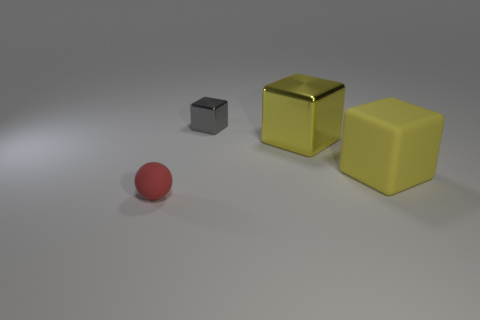Add 2 small gray objects. How many objects exist? 6 Subtract all spheres. How many objects are left? 3 Subtract 0 brown blocks. How many objects are left? 4 Subtract all small red spheres. Subtract all big green rubber cylinders. How many objects are left? 3 Add 2 matte objects. How many matte objects are left? 4 Add 2 tiny gray metal things. How many tiny gray metal things exist? 3 